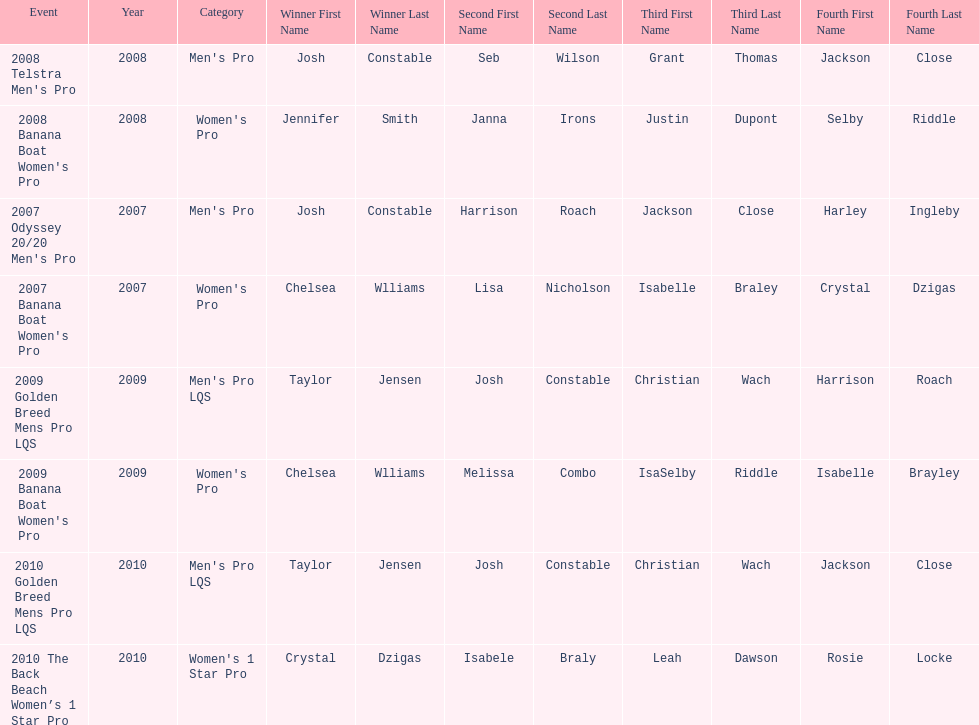Parse the table in full. {'header': ['Event', 'Year', 'Category', 'Winner First Name', 'Winner Last Name', 'Second First Name', 'Second Last Name', 'Third First Name', 'Third Last Name', 'Fourth First Name', 'Fourth Last Name'], 'rows': [["2008 Telstra Men's Pro", '2008', "Men's Pro", 'Josh', 'Constable', 'Seb', 'Wilson', 'Grant', 'Thomas', 'Jackson', 'Close'], ["2008 Banana Boat Women's Pro", '2008', "Women's Pro", 'Jennifer', 'Smith', 'Janna', 'Irons', 'Justin', 'Dupont', 'Selby', 'Riddle'], ["2007 Odyssey 20/20 Men's Pro", '2007', "Men's Pro", 'Josh', 'Constable', 'Harrison', 'Roach', 'Jackson', 'Close', 'Harley', 'Ingleby'], ["2007 Banana Boat Women's Pro", '2007', "Women's Pro", 'Chelsea', 'Wlliams', 'Lisa', 'Nicholson', 'Isabelle', 'Braley', 'Crystal', 'Dzigas'], ['2009 Golden Breed Mens Pro LQS', '2009', "Men's Pro LQS", 'Taylor', 'Jensen', 'Josh', 'Constable', 'Christian', 'Wach', 'Harrison', 'Roach'], ["2009 Banana Boat Women's Pro", '2009', "Women's Pro", 'Chelsea', 'Wlliams', 'Melissa', 'Combo', 'IsaSelby', 'Riddle', 'Isabelle', 'Brayley'], ['2010 Golden Breed Mens Pro LQS', '2010', "Men's Pro LQS", 'Taylor', 'Jensen', 'Josh', 'Constable', 'Christian', 'Wach', 'Jackson', 'Close'], ['2010 The Back Beach Women’s 1 Star Pro', '2010', "Women's 1 Star Pro", 'Crystal', 'Dzigas', 'Isabele', 'Braly', 'Leah', 'Dawson', 'Rosie', 'Locke']]} How many times was josh constable second? 2. 